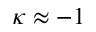<formula> <loc_0><loc_0><loc_500><loc_500>\kappa \approx - 1</formula> 